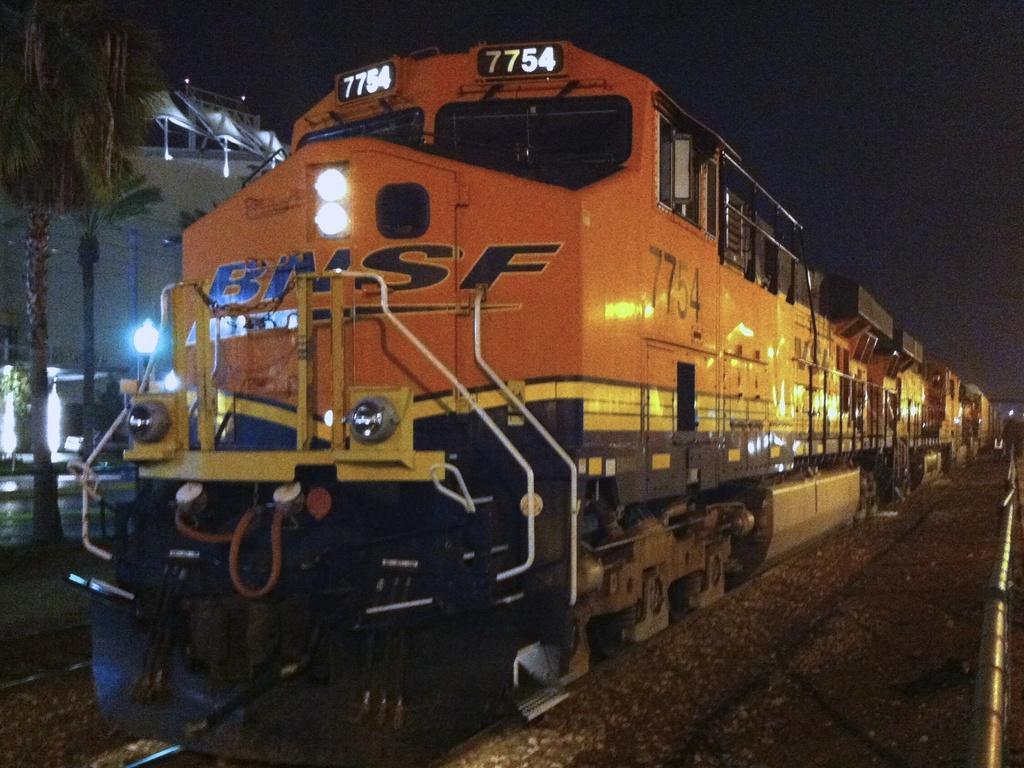How would you summarize this image in a sentence or two? In this image I can see the train on the railway track. Train is in orange and yellow color. Back I can see few trees, lights and the building. 